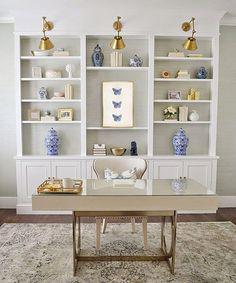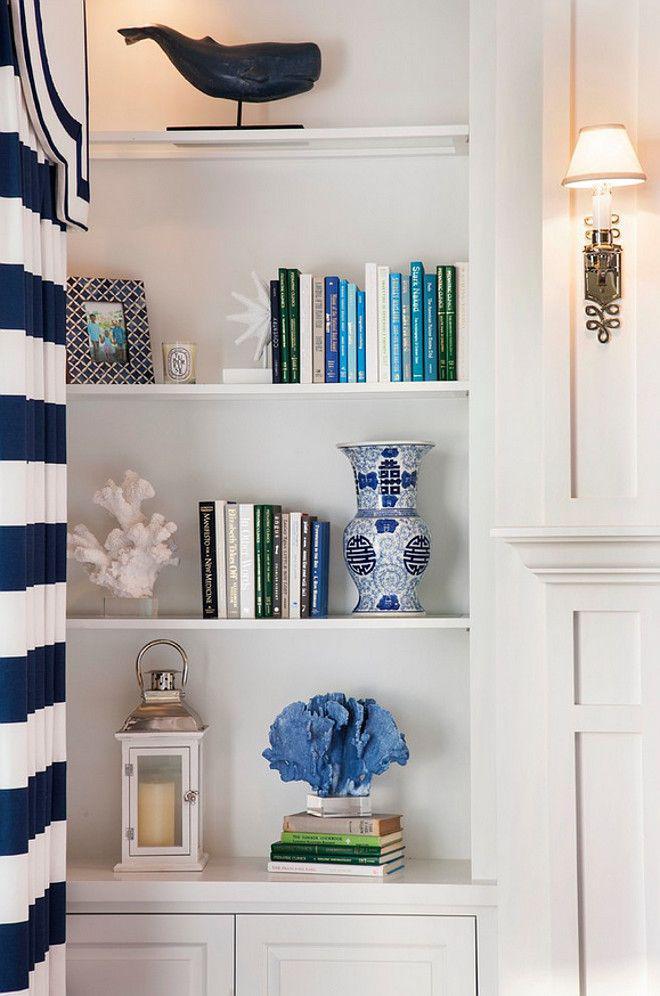The first image is the image on the left, the second image is the image on the right. Analyze the images presented: Is the assertion "There is exactly one chair in the image on the left." valid? Answer yes or no. Yes. 